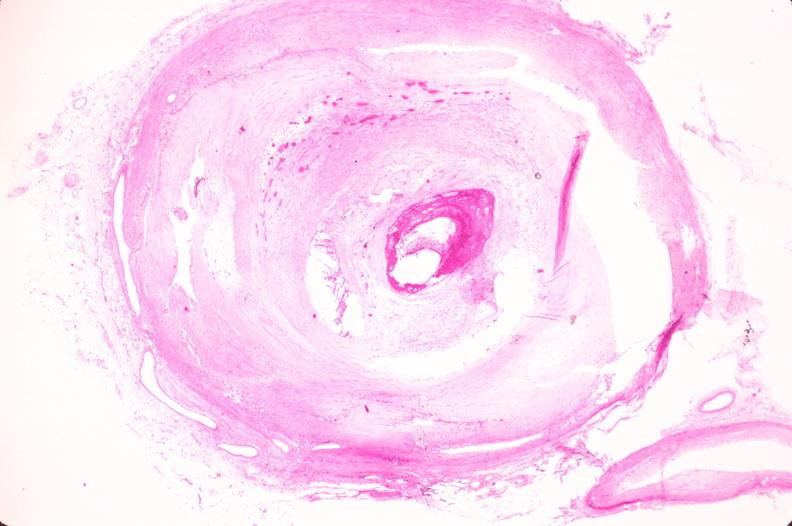s cardiovascular present?
Answer the question using a single word or phrase. Yes 